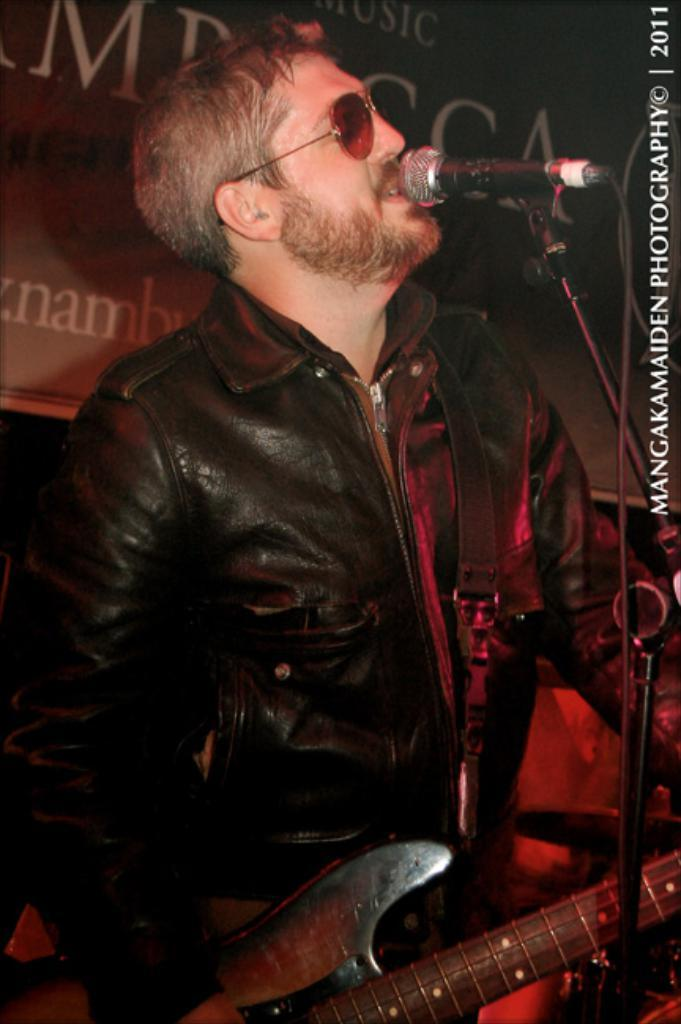What is the person in the image doing? The person is standing and singing a song. What is the person holding in the image? The person is holding a guitar. What can be seen on the person's face in the image? The person is wearing a spectacle. What is visible in the background of the image? There is a banner visible in the background. What type of curtain is hanging in the background of the image? There is no curtain visible in the background of the image. Can you tell me how many dogs are present in the image? There are no dogs present in the image. 